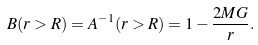Convert formula to latex. <formula><loc_0><loc_0><loc_500><loc_500>B ( r > R ) = A ^ { - 1 } ( r > R ) = 1 - \frac { 2 M G } { r } .</formula> 